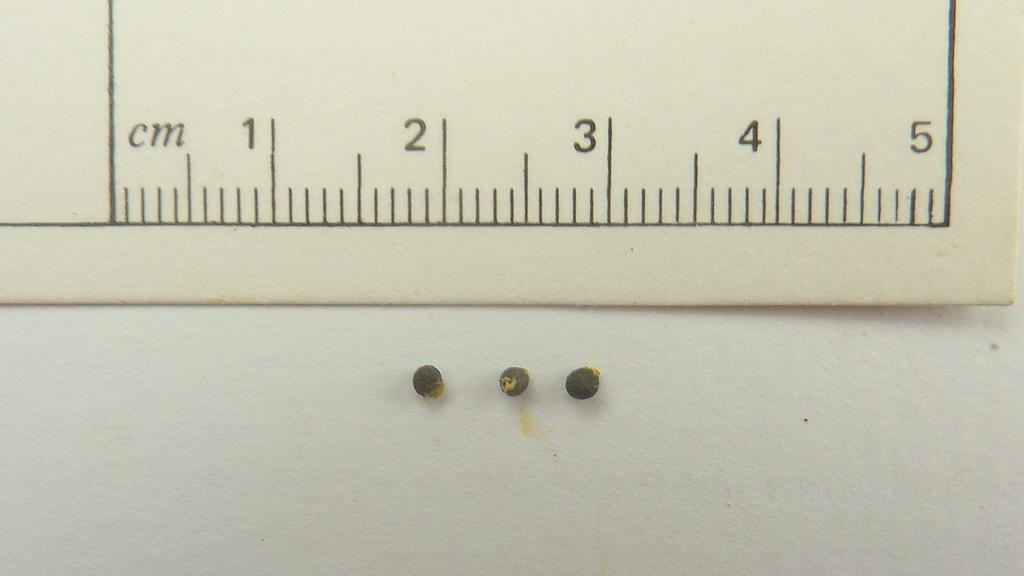<image>
Summarize the visual content of the image. a ruler measuring centimeters is above three seeds 